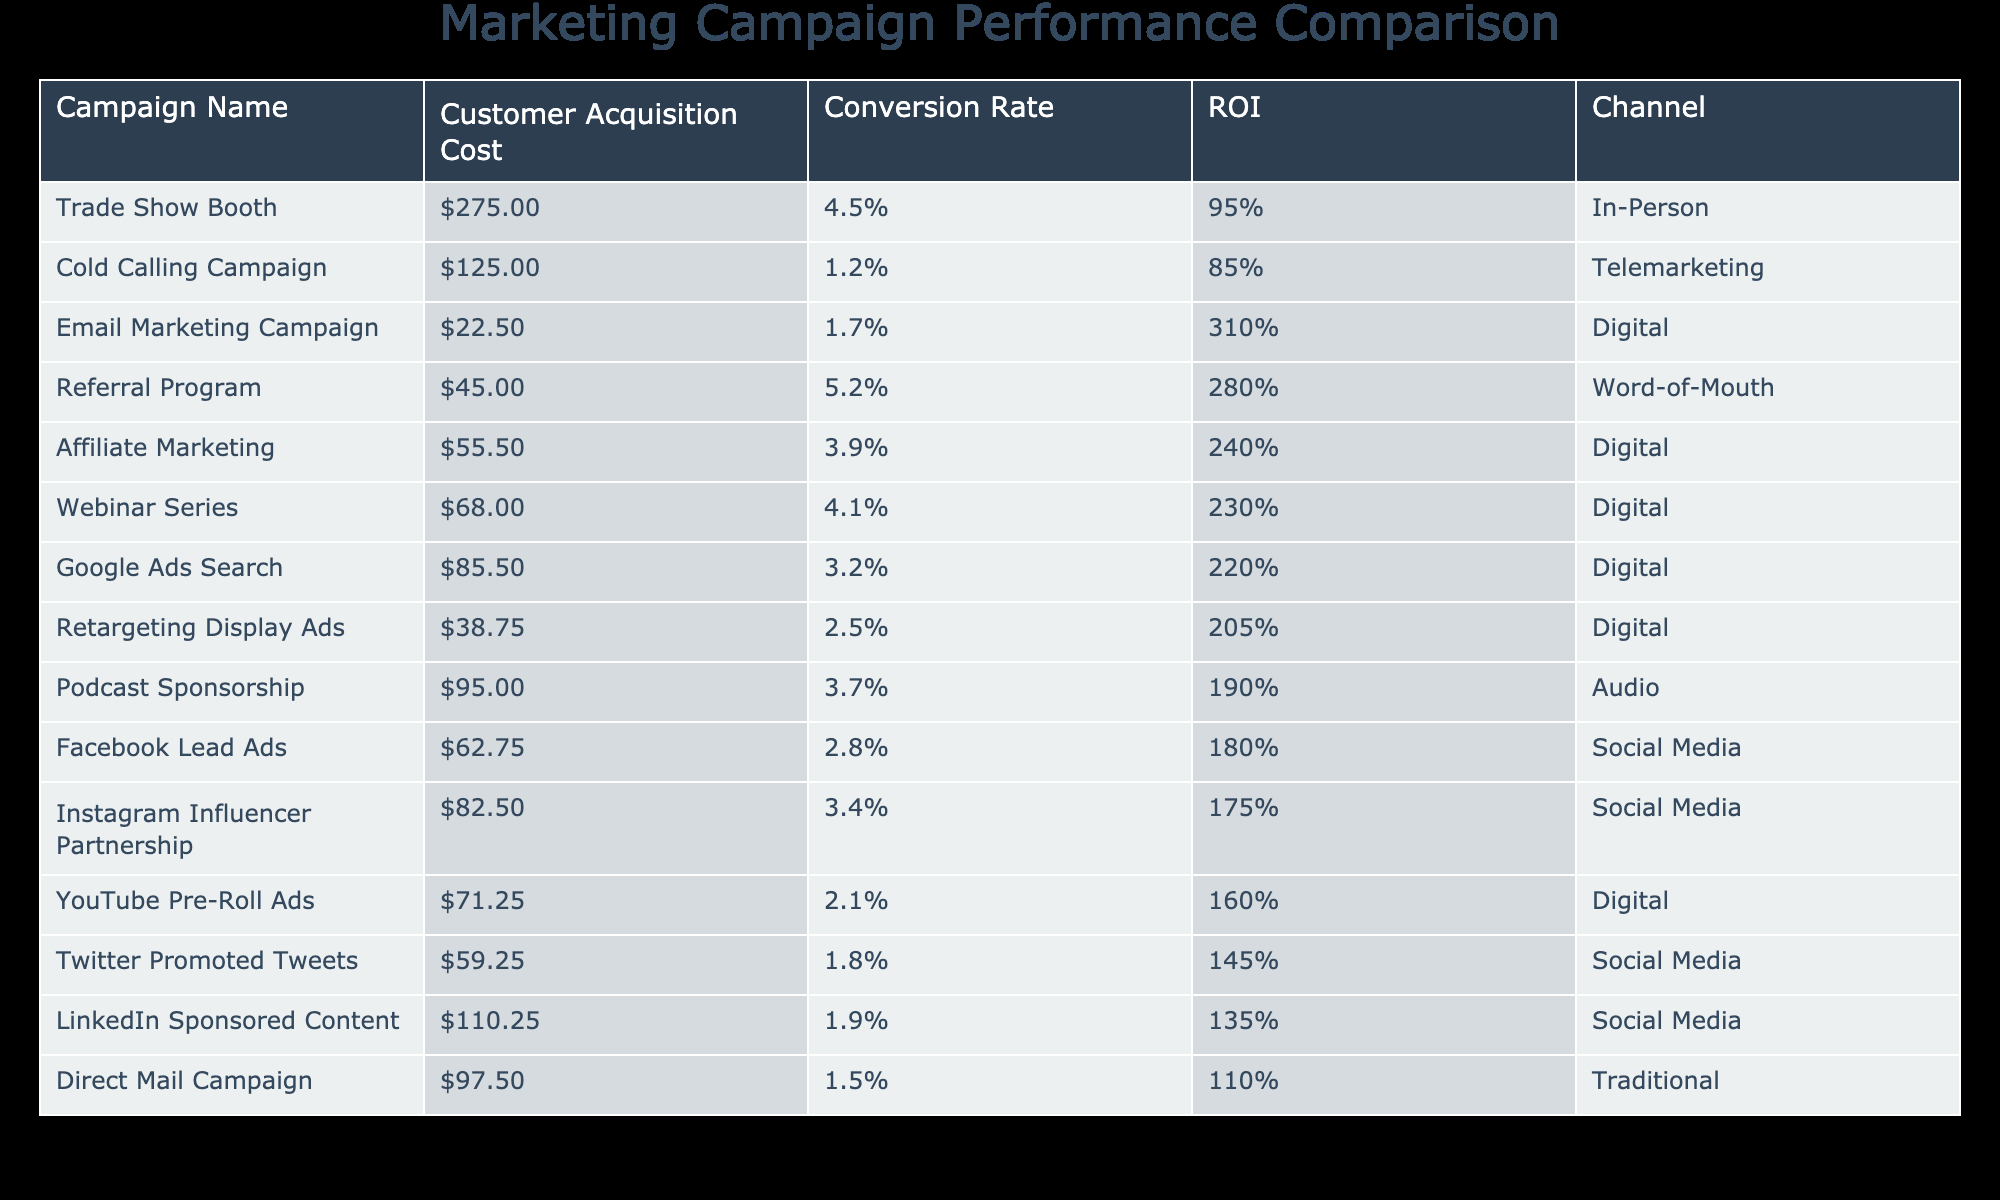What is the Customer Acquisition Cost of the Email Marketing Campaign? The Customer Acquisition Cost for the Email Marketing Campaign is specifically listed in the table as $22.50.
Answer: $22.50 Which campaign has the highest Conversion Rate? The Conversion Rate is 4.5% for the Trade Show Booth, which is the highest among all listed campaigns in the table.
Answer: Trade Show Booth What is the total Customer Acquisition Cost for Digital campaigns? The Digital campaigns in the table are Google Ads Search, Email Marketing Campaign, YouTube Pre-Roll Ads, Affiliate Marketing, Retargeting Display Ads, and Webinar Series. Their costs are $85.50, $22.50, $71.25, $55.50, $38.75, and $68.00 respectively. Summing these gives $341.50.
Answer: $341.50 Is the ROI of the LinkedIn Sponsored Content greater than or equal to 150%? The ROI of the LinkedIn Sponsored Content is given as 135%, which is less than 150%, so the statement is false.
Answer: False What is the average Customer Acquisition Cost for Social Media campaigns? The Social Media campaigns in the table are Facebook Lead Ads, LinkedIn Sponsored Content, Instagram Influencer Partnership, and Twitter Promoted Tweets, with costs of $62.75, $110.25, $82.50, and $59.25. Summing these gives $314.75, and dividing by 4 results in an average of $78.69.
Answer: $78.69 Which campaign has the best ROI and what is its value? The campaign with the best ROI is the Email Marketing Campaign, with a value of 310%. This can be found directly from the ROI column in the table.
Answer: Email Marketing Campaign, 310% Do all campaigns have a Customer Acquisition Cost below $300? Evaluating the Customer Acquisition Costs in the table, only the Trade Show Booth exceeds $275. Therefore, it is true that not all campaigns are below $300.
Answer: False If we consider only the campaigns with a Conversion Rate over 3%, which one has the lowest Customer Acquisition Cost? The campaigns with a Conversion Rate over 3% are Google Ads Search (3.2%), Facebook Lead Ads (2.8%), Instagram Influencer Partnership (3.4%), and Webinar Series (4.1%). Among these, the Facebook Lead Ads has the lowest Customer Acquisition Cost of $62.75.
Answer: Facebook Lead Ads, $62.75 What is the difference in ROI between the highest and lowest performing campaigns? The highest ROI is 310% from the Email Marketing Campaign, while the lowest is 85% from the Cold Calling Campaign. The difference in ROI is 310% - 85% = 225%.
Answer: 225% 